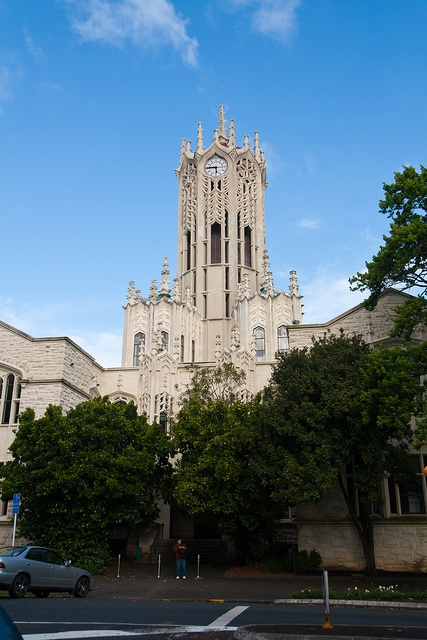Describe the objects in this image and their specific colors. I can see car in gray, black, blue, and darkblue tones, people in gray, black, darkblue, and maroon tones, and clock in gray, darkgray, lightgray, and black tones in this image. 